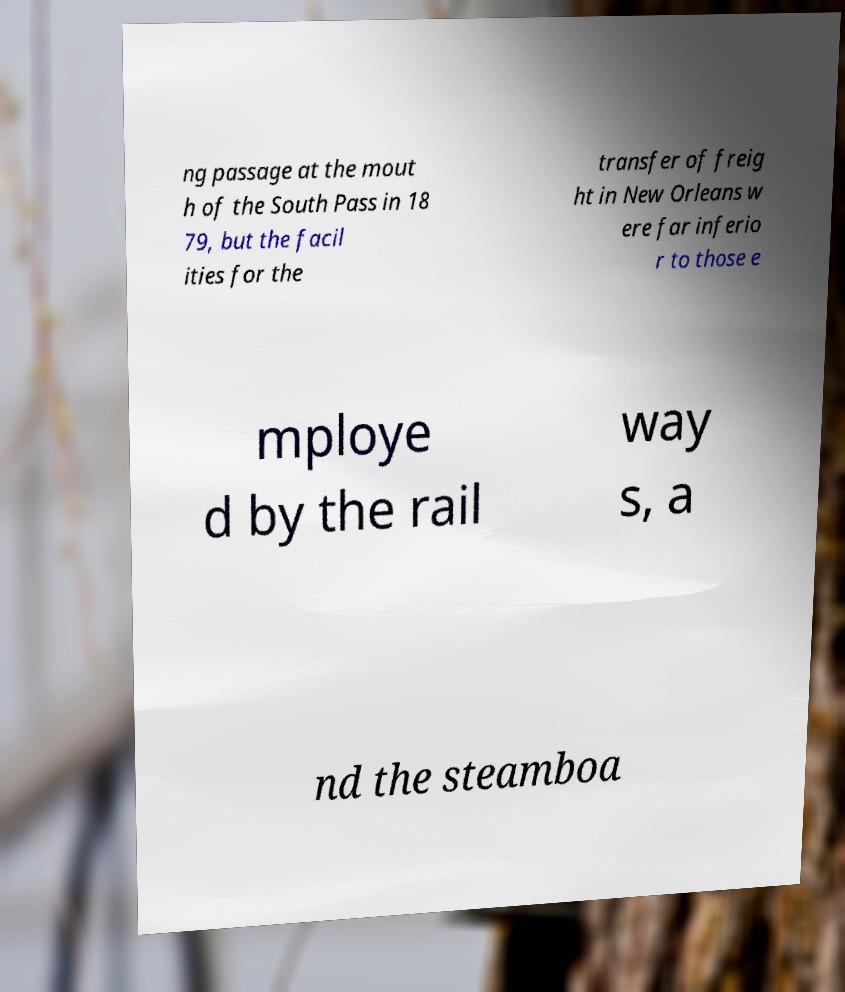Could you extract and type out the text from this image? ng passage at the mout h of the South Pass in 18 79, but the facil ities for the transfer of freig ht in New Orleans w ere far inferio r to those e mploye d by the rail way s, a nd the steamboa 